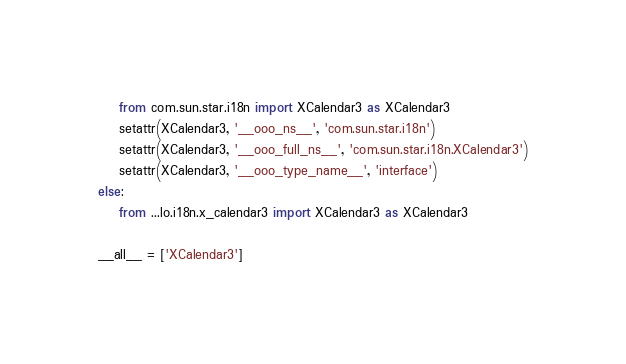Convert code to text. <code><loc_0><loc_0><loc_500><loc_500><_Python_>    from com.sun.star.i18n import XCalendar3 as XCalendar3
    setattr(XCalendar3, '__ooo_ns__', 'com.sun.star.i18n')
    setattr(XCalendar3, '__ooo_full_ns__', 'com.sun.star.i18n.XCalendar3')
    setattr(XCalendar3, '__ooo_type_name__', 'interface')
else:
    from ...lo.i18n.x_calendar3 import XCalendar3 as XCalendar3

__all__ = ['XCalendar3']

</code> 